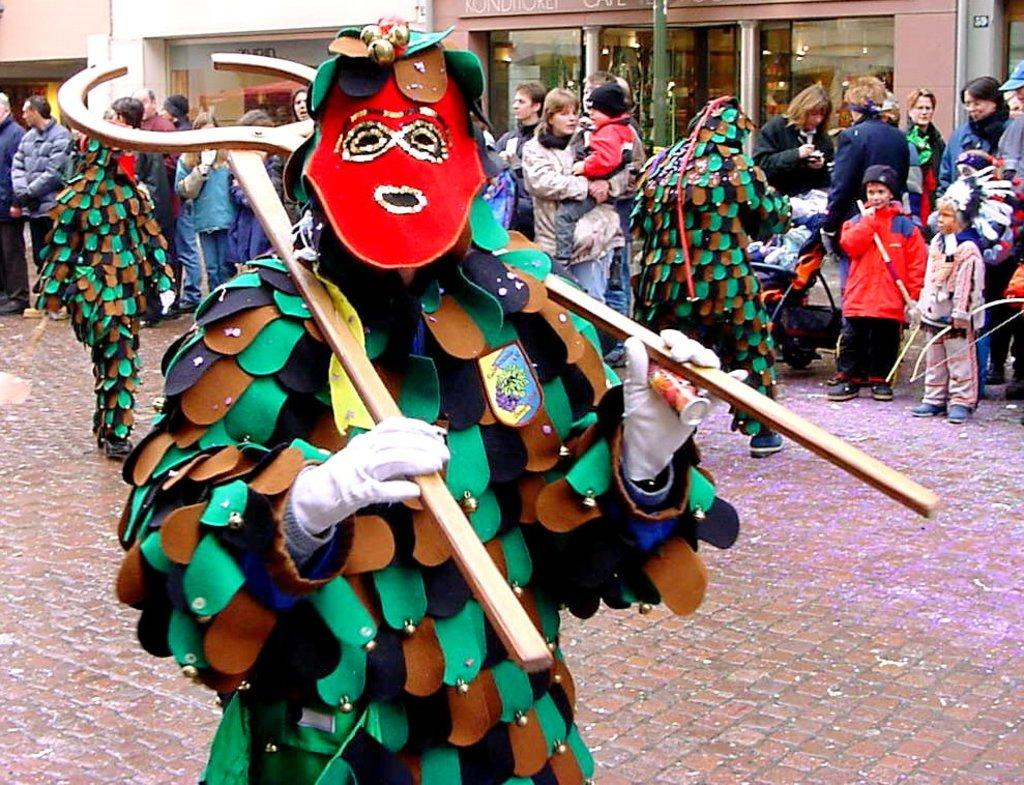What are the persons in the image wearing? The persons in the image are wearing fancy dresses. How are the people in the image positioned? There is a group of people standing in the image. What can be seen in the background of the image? There are buildings in the background of the image. What type of bread can be seen in the hands of the persons in the image? There is no bread present in the image; the persons are wearing fancy dresses and standing in a group. 